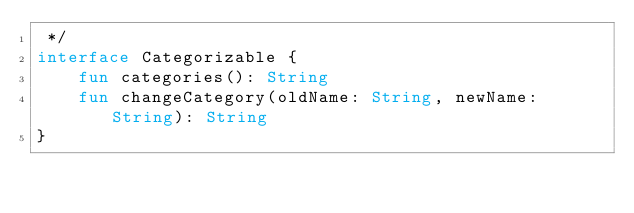<code> <loc_0><loc_0><loc_500><loc_500><_Kotlin_> */
interface Categorizable {
	fun categories(): String
	fun changeCategory(oldName: String, newName: String): String
}
</code> 